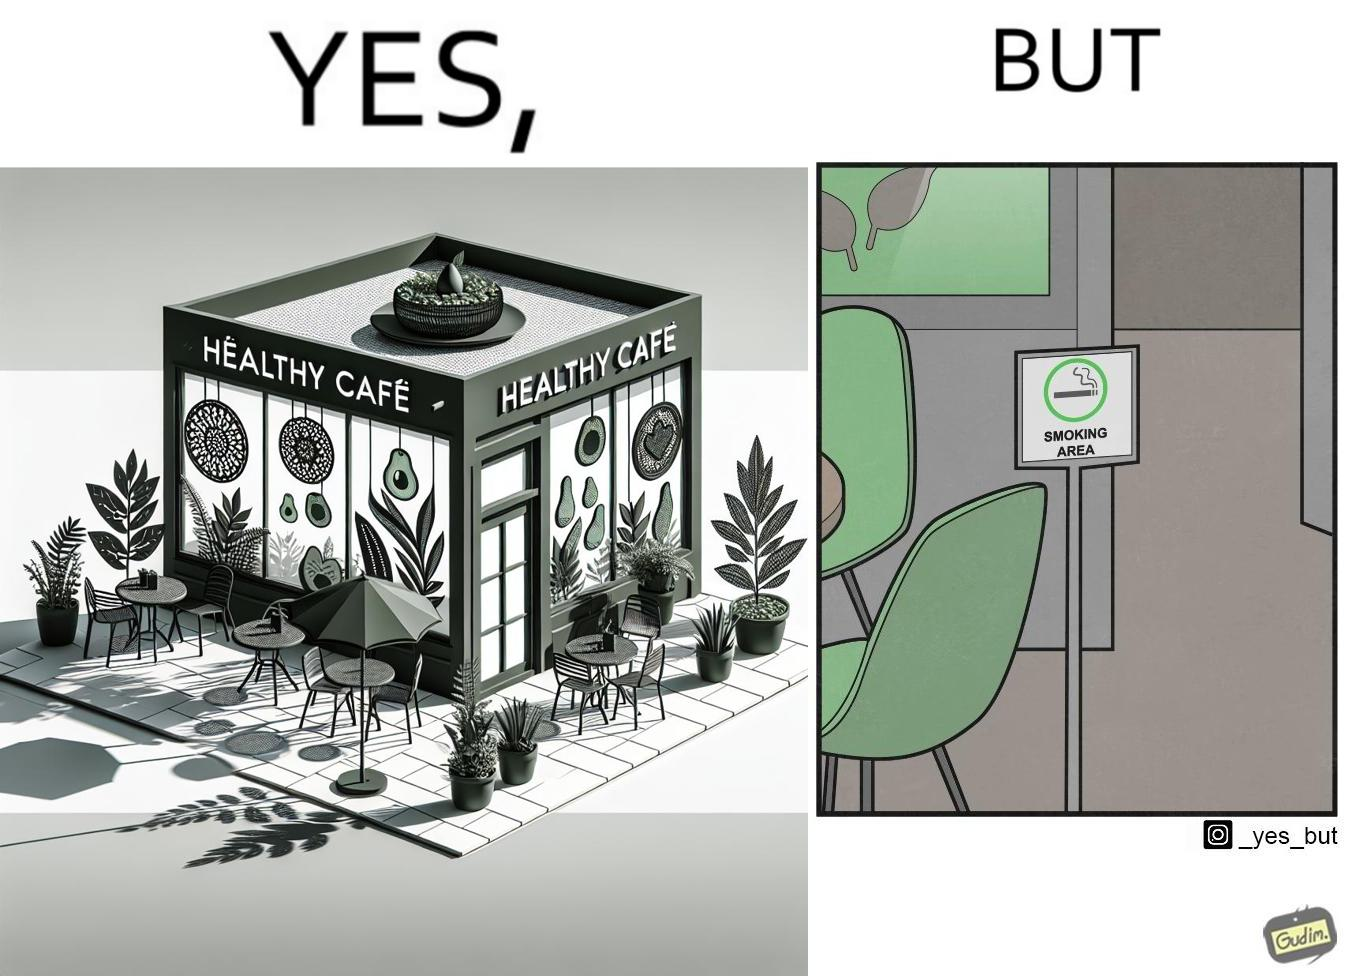What is shown in the left half versus the right half of this image? In the left part of the image: An eatery with the name "Healthy Cafe". It has a green aesthetic with paintings of leaves, avocados, etc on their windows. They have an outdoor seating area with 4 green patio chairs around a circular table. There is a small sign on a stand near the table with a green circular symbol and some text that is too small to read. In the right part of the image: Green patio chairs. A sign on a stand that has a green circular symbol encircling a cigarette symbol, and some text that says "SMOKING AREA". 